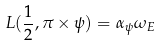Convert formula to latex. <formula><loc_0><loc_0><loc_500><loc_500>L ( \frac { 1 } { 2 } , \pi \times \psi ) = \alpha _ { \psi } \omega _ { E }</formula> 